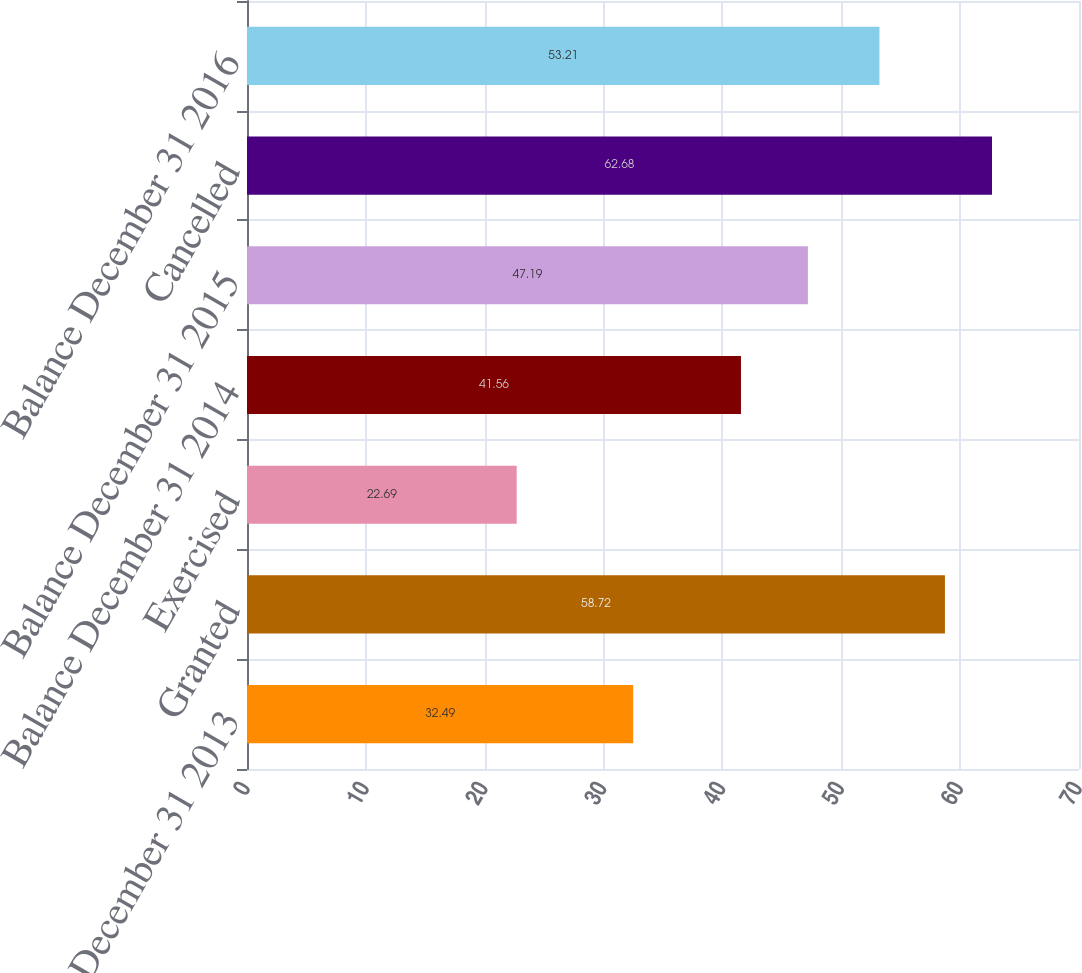Convert chart to OTSL. <chart><loc_0><loc_0><loc_500><loc_500><bar_chart><fcel>Balance December 31 2013<fcel>Granted<fcel>Exercised<fcel>Balance December 31 2014<fcel>Balance December 31 2015<fcel>Cancelled<fcel>Balance December 31 2016<nl><fcel>32.49<fcel>58.72<fcel>22.69<fcel>41.56<fcel>47.19<fcel>62.68<fcel>53.21<nl></chart> 